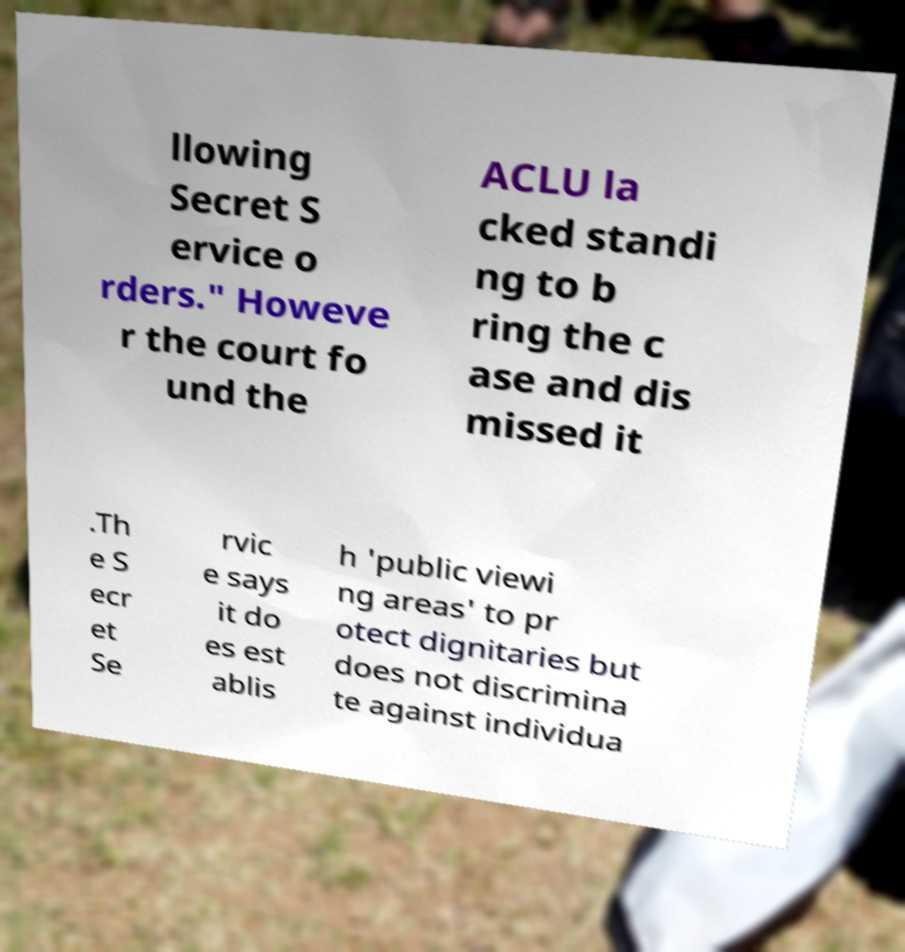Can you read and provide the text displayed in the image?This photo seems to have some interesting text. Can you extract and type it out for me? llowing Secret S ervice o rders." Howeve r the court fo und the ACLU la cked standi ng to b ring the c ase and dis missed it .Th e S ecr et Se rvic e says it do es est ablis h 'public viewi ng areas' to pr otect dignitaries but does not discrimina te against individua 